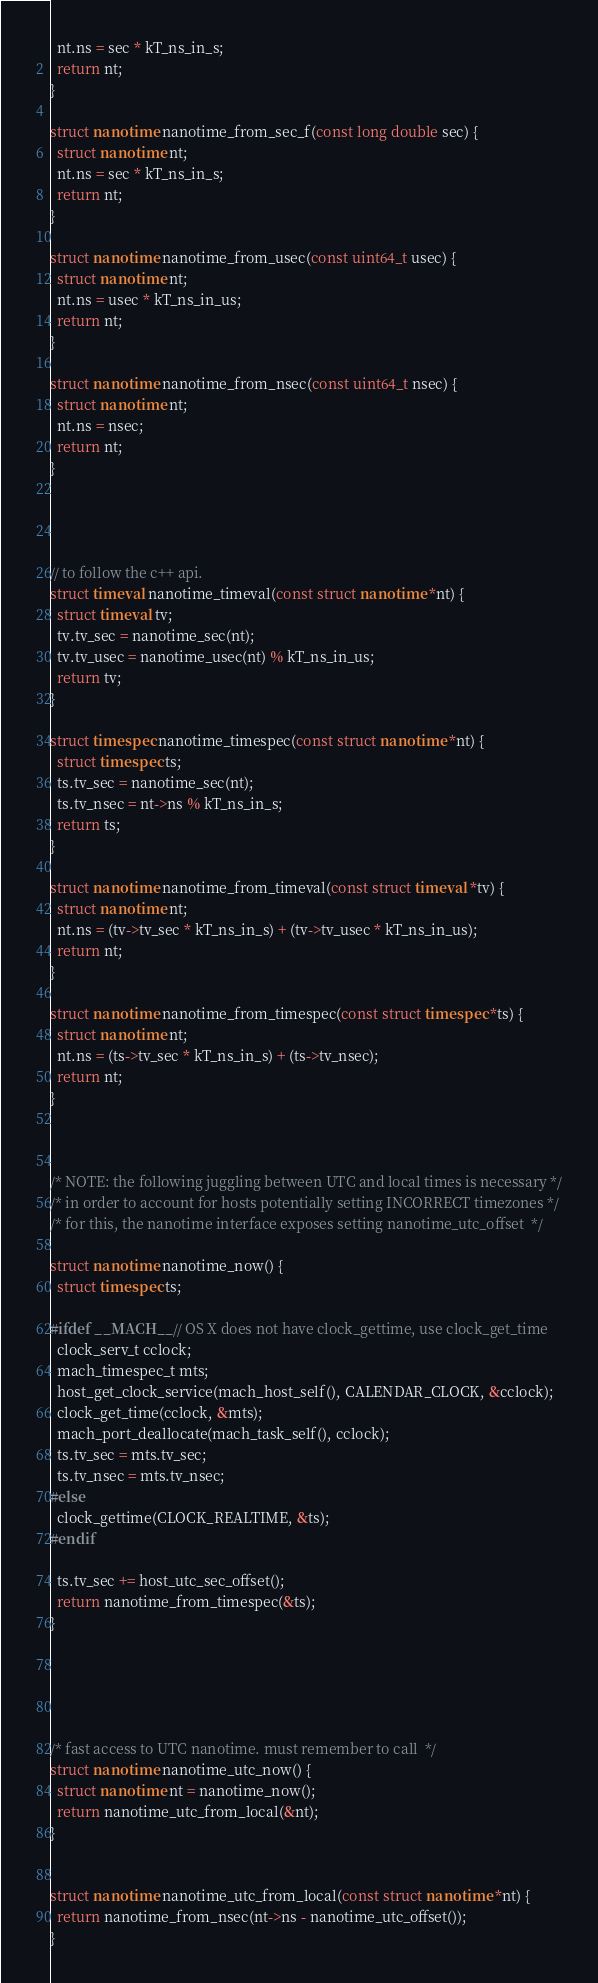Convert code to text. <code><loc_0><loc_0><loc_500><loc_500><_C_>  nt.ns = sec * kT_ns_in_s;
  return nt;
}

struct nanotime nanotime_from_sec_f(const long double sec) {
  struct nanotime nt;
  nt.ns = sec * kT_ns_in_s;
  return nt;
}

struct nanotime nanotime_from_usec(const uint64_t usec) {
  struct nanotime nt;
  nt.ns = usec * kT_ns_in_us;
  return nt;
}

struct nanotime nanotime_from_nsec(const uint64_t nsec) {
  struct nanotime nt;
  nt.ns = nsec;
  return nt;
}




// to follow the c++ api.
struct timeval nanotime_timeval(const struct nanotime *nt) {
  struct timeval tv;
  tv.tv_sec = nanotime_sec(nt);
  tv.tv_usec = nanotime_usec(nt) % kT_ns_in_us;
  return tv;
}

struct timespec nanotime_timespec(const struct nanotime *nt) {
  struct timespec ts;
  ts.tv_sec = nanotime_sec(nt);
  ts.tv_nsec = nt->ns % kT_ns_in_s;
  return ts;
}

struct nanotime nanotime_from_timeval(const struct timeval *tv) {
  struct nanotime nt;
  nt.ns = (tv->tv_sec * kT_ns_in_s) + (tv->tv_usec * kT_ns_in_us);
  return nt;
}

struct nanotime nanotime_from_timespec(const struct timespec *ts) {
  struct nanotime nt;
  nt.ns = (ts->tv_sec * kT_ns_in_s) + (ts->tv_nsec);
  return nt;
}



/* NOTE: the following juggling between UTC and local times is necessary */
/* in order to account for hosts potentially setting INCORRECT timezones */
/* for this, the nanotime interface exposes setting nanotime_utc_offset  */

struct nanotime nanotime_now() {
  struct timespec ts;

#ifdef __MACH__ // OS X does not have clock_gettime, use clock_get_time
  clock_serv_t cclock;
  mach_timespec_t mts;
  host_get_clock_service(mach_host_self(), CALENDAR_CLOCK, &cclock);
  clock_get_time(cclock, &mts);
  mach_port_deallocate(mach_task_self(), cclock);
  ts.tv_sec = mts.tv_sec;
  ts.tv_nsec = mts.tv_nsec;
#else
  clock_gettime(CLOCK_REALTIME, &ts);
#endif

  ts.tv_sec += host_utc_sec_offset();
  return nanotime_from_timespec(&ts);
}





/* fast access to UTC nanotime. must remember to call  */
struct nanotime nanotime_utc_now() {
  struct nanotime nt = nanotime_now();
  return nanotime_utc_from_local(&nt);
}


struct nanotime nanotime_utc_from_local(const struct nanotime *nt) {
  return nanotime_from_nsec(nt->ns - nanotime_utc_offset());
}
</code> 